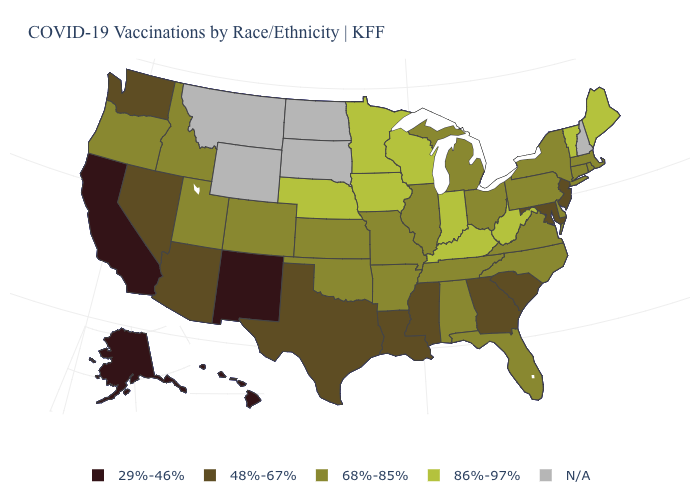What is the value of Washington?
Be succinct. 48%-67%. What is the value of Pennsylvania?
Be succinct. 68%-85%. Does the first symbol in the legend represent the smallest category?
Be succinct. Yes. Name the states that have a value in the range 68%-85%?
Be succinct. Alabama, Arkansas, Colorado, Connecticut, Delaware, Florida, Idaho, Illinois, Kansas, Massachusetts, Michigan, Missouri, New York, North Carolina, Ohio, Oklahoma, Oregon, Pennsylvania, Rhode Island, Tennessee, Utah, Virginia. Name the states that have a value in the range N/A?
Short answer required. Montana, New Hampshire, North Dakota, South Dakota, Wyoming. Name the states that have a value in the range 48%-67%?
Answer briefly. Arizona, Georgia, Louisiana, Maryland, Mississippi, Nevada, New Jersey, South Carolina, Texas, Washington. Does Missouri have the highest value in the USA?
Answer briefly. No. Does Massachusetts have the highest value in the USA?
Quick response, please. No. What is the value of Indiana?
Keep it brief. 86%-97%. What is the value of Maryland?
Write a very short answer. 48%-67%. Which states hav the highest value in the South?
Be succinct. Kentucky, West Virginia. Name the states that have a value in the range N/A?
Keep it brief. Montana, New Hampshire, North Dakota, South Dakota, Wyoming. Does Colorado have the highest value in the USA?
Quick response, please. No. Name the states that have a value in the range N/A?
Write a very short answer. Montana, New Hampshire, North Dakota, South Dakota, Wyoming. 